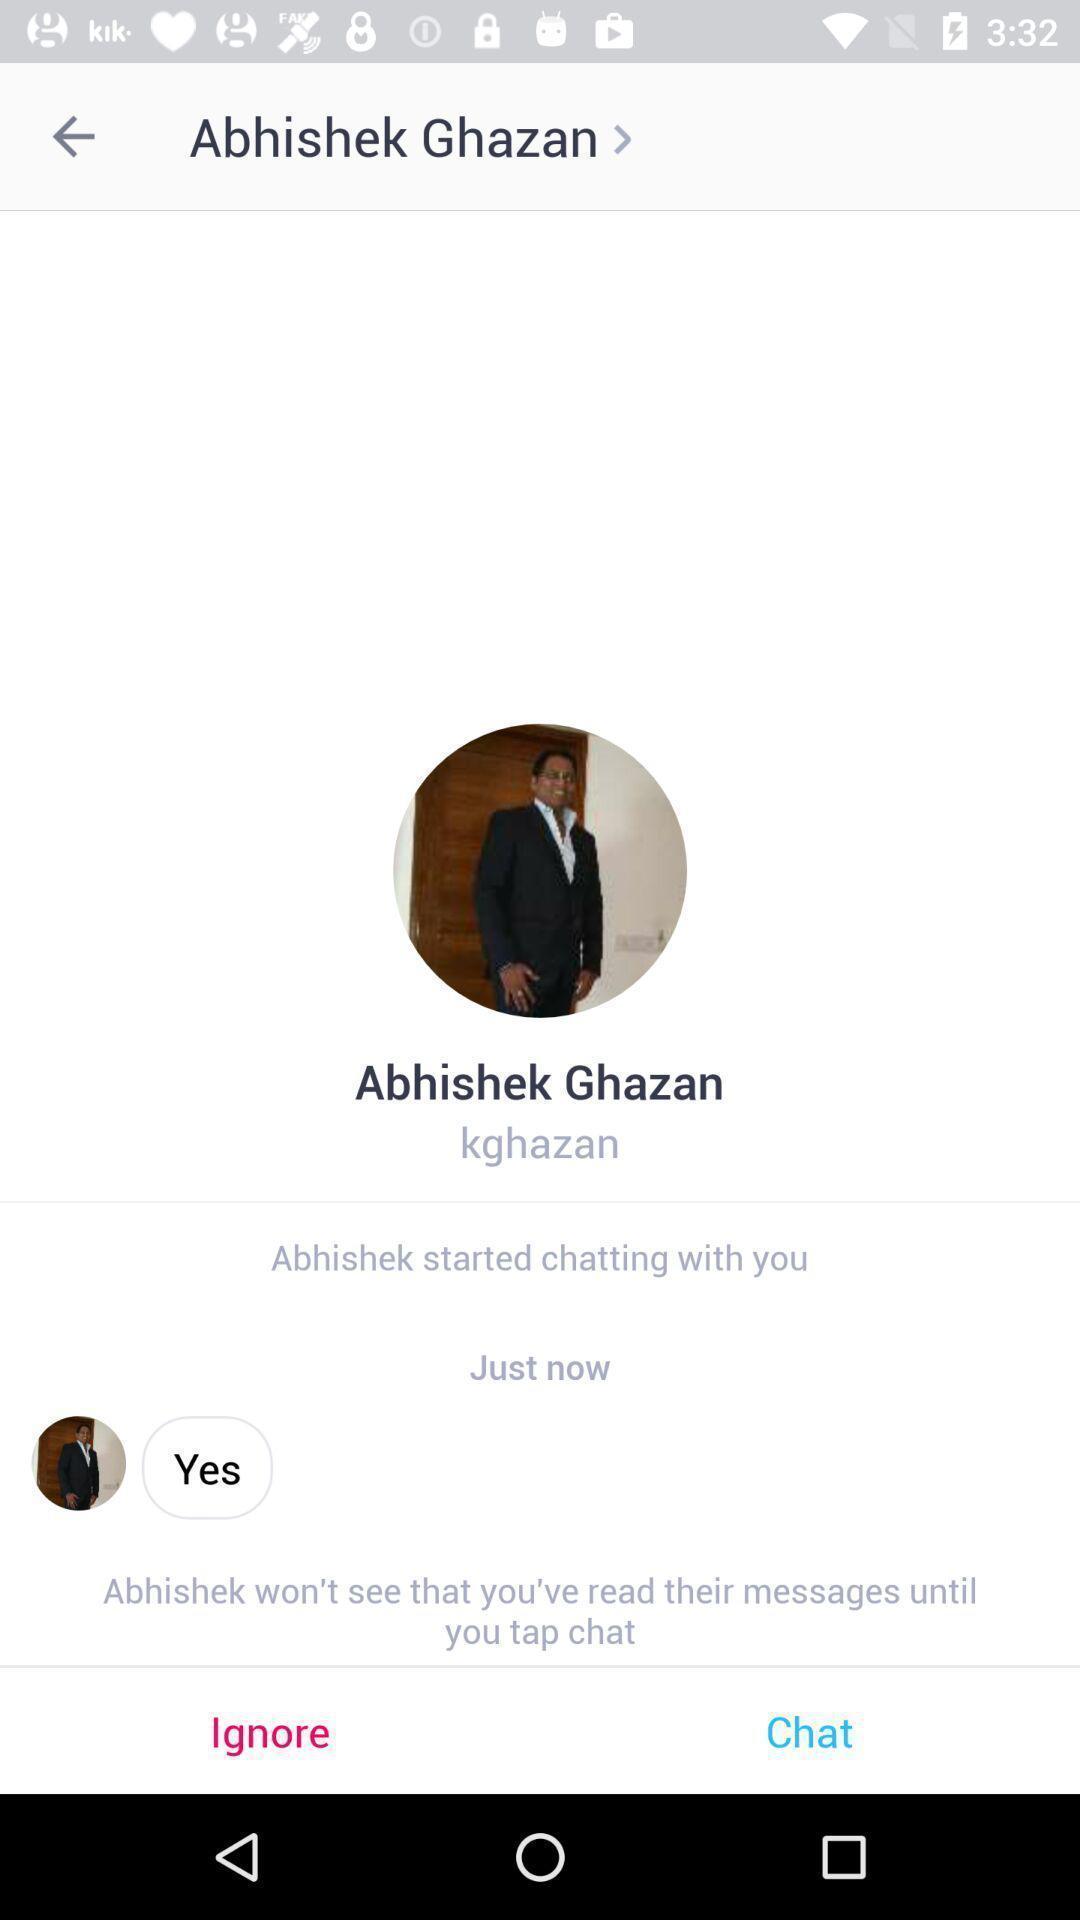Explain the elements present in this screenshot. Screen showing a conversation on a social app. 